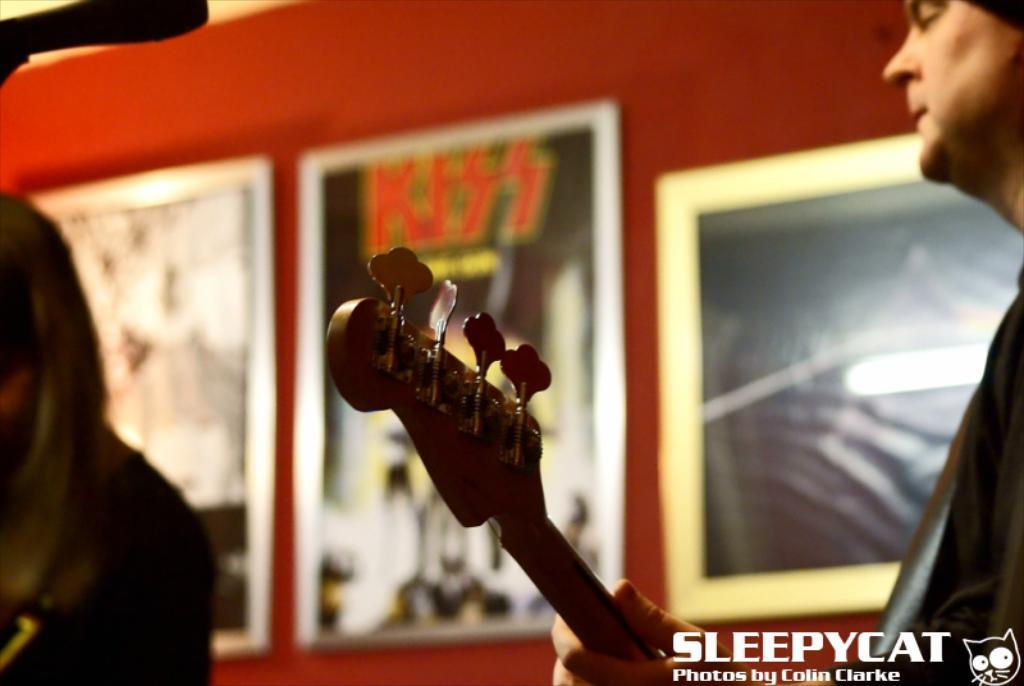How many people are in the image? There are two men in the image. What is one of the men doing in the image? One person is playing a guitar. On which side of the image is the guitar player located? The guitar player is on the right side of the image. What can be seen on the wall in the background of the image? There are frames on the wall in the background. What type of sack is being used to carry the heart in the image? There is no sack or heart present in the image; it features two men, one of whom is playing a guitar. 